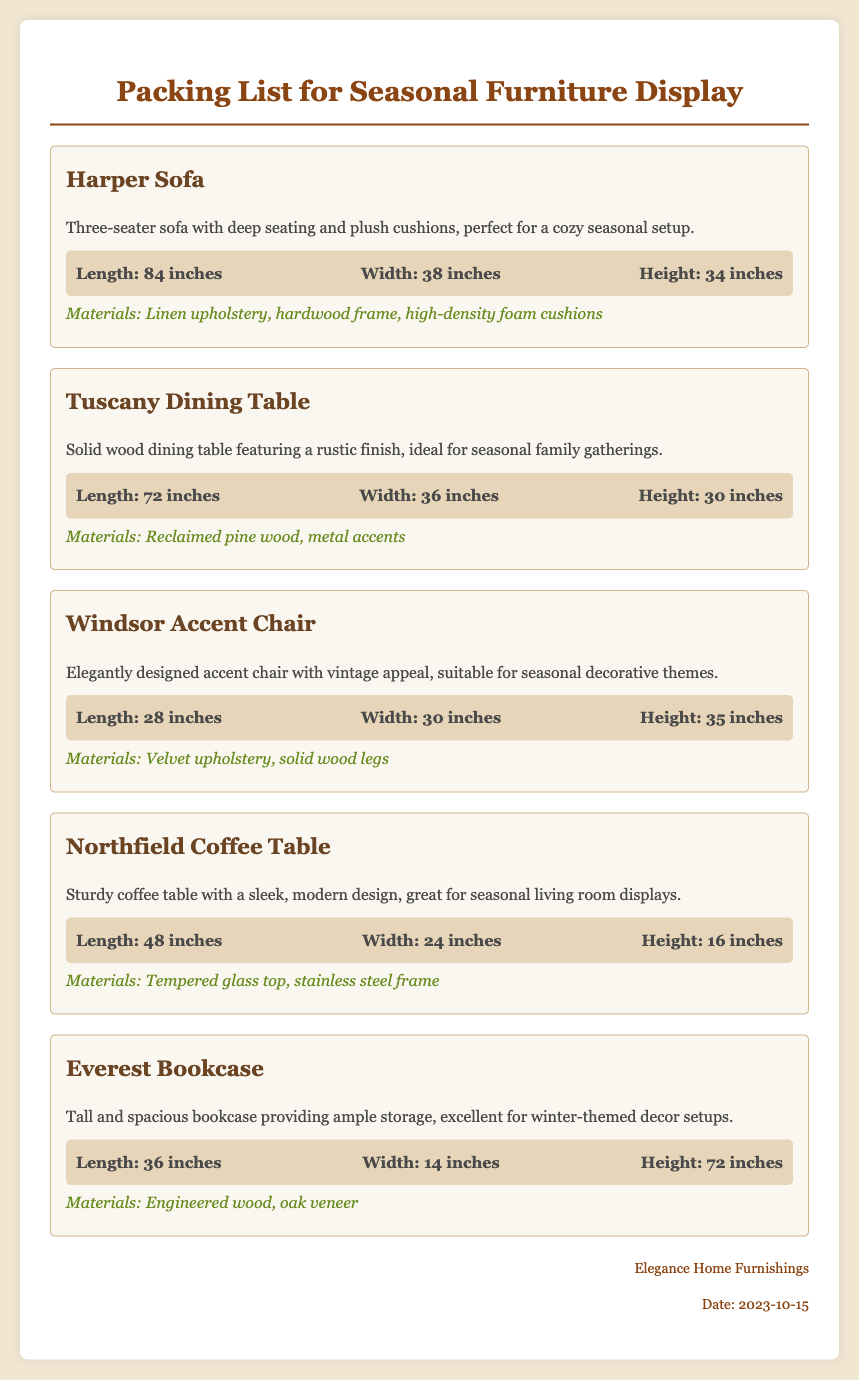What is the name of the coffee table? The document lists the name of the coffee table as "Northfield Coffee Table."
Answer: Northfield Coffee Table What are the dimensions of the Tuscany Dining Table? The dimensions of the Tuscany Dining Table are provided in the document as Length: 72 inches, Width: 36 inches, Height: 30 inches.
Answer: Length: 72 inches, Width: 36 inches, Height: 30 inches What materials are used in the Harper Sofa? The materials used in the Harper Sofa are specified in the document as Linen upholstery, hardwood frame, high-density foam cushions.
Answer: Linen upholstery, hardwood frame, high-density foam cushions How many inches tall is the Everest Bookcase? The height of the Everest Bookcase is detailed in the document as 72 inches.
Answer: 72 inches Which item is suitable for decorative themes? The document states that the Windsor Accent Chair is suitable for seasonal decorative themes.
Answer: Windsor Accent Chair What type of document is this? The document is specifically a packing list for a seasonal furniture display.
Answer: Packing list for seasonal furniture display 